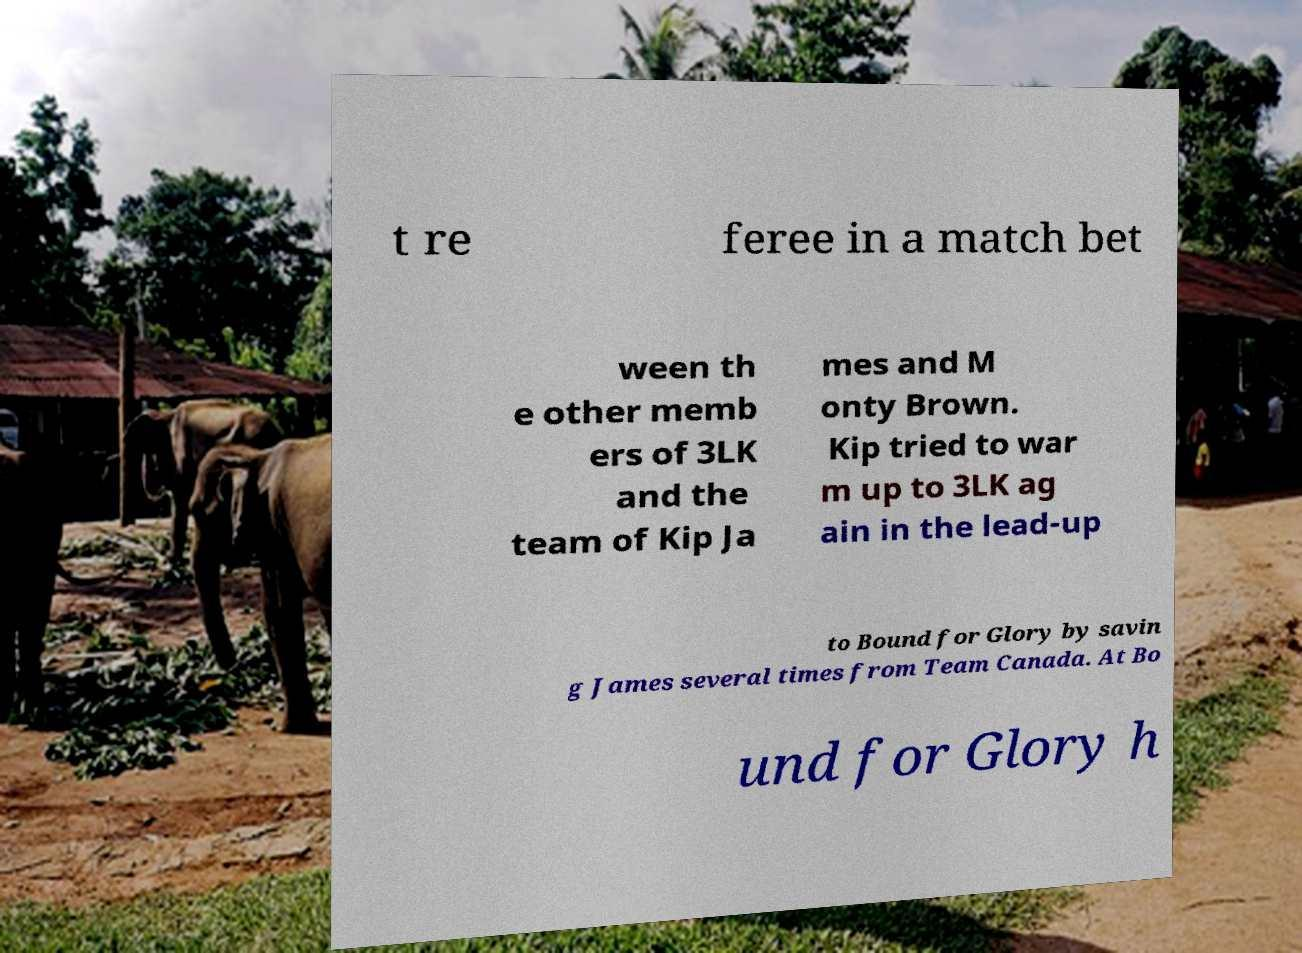For documentation purposes, I need the text within this image transcribed. Could you provide that? t re feree in a match bet ween th e other memb ers of 3LK and the team of Kip Ja mes and M onty Brown. Kip tried to war m up to 3LK ag ain in the lead-up to Bound for Glory by savin g James several times from Team Canada. At Bo und for Glory h 